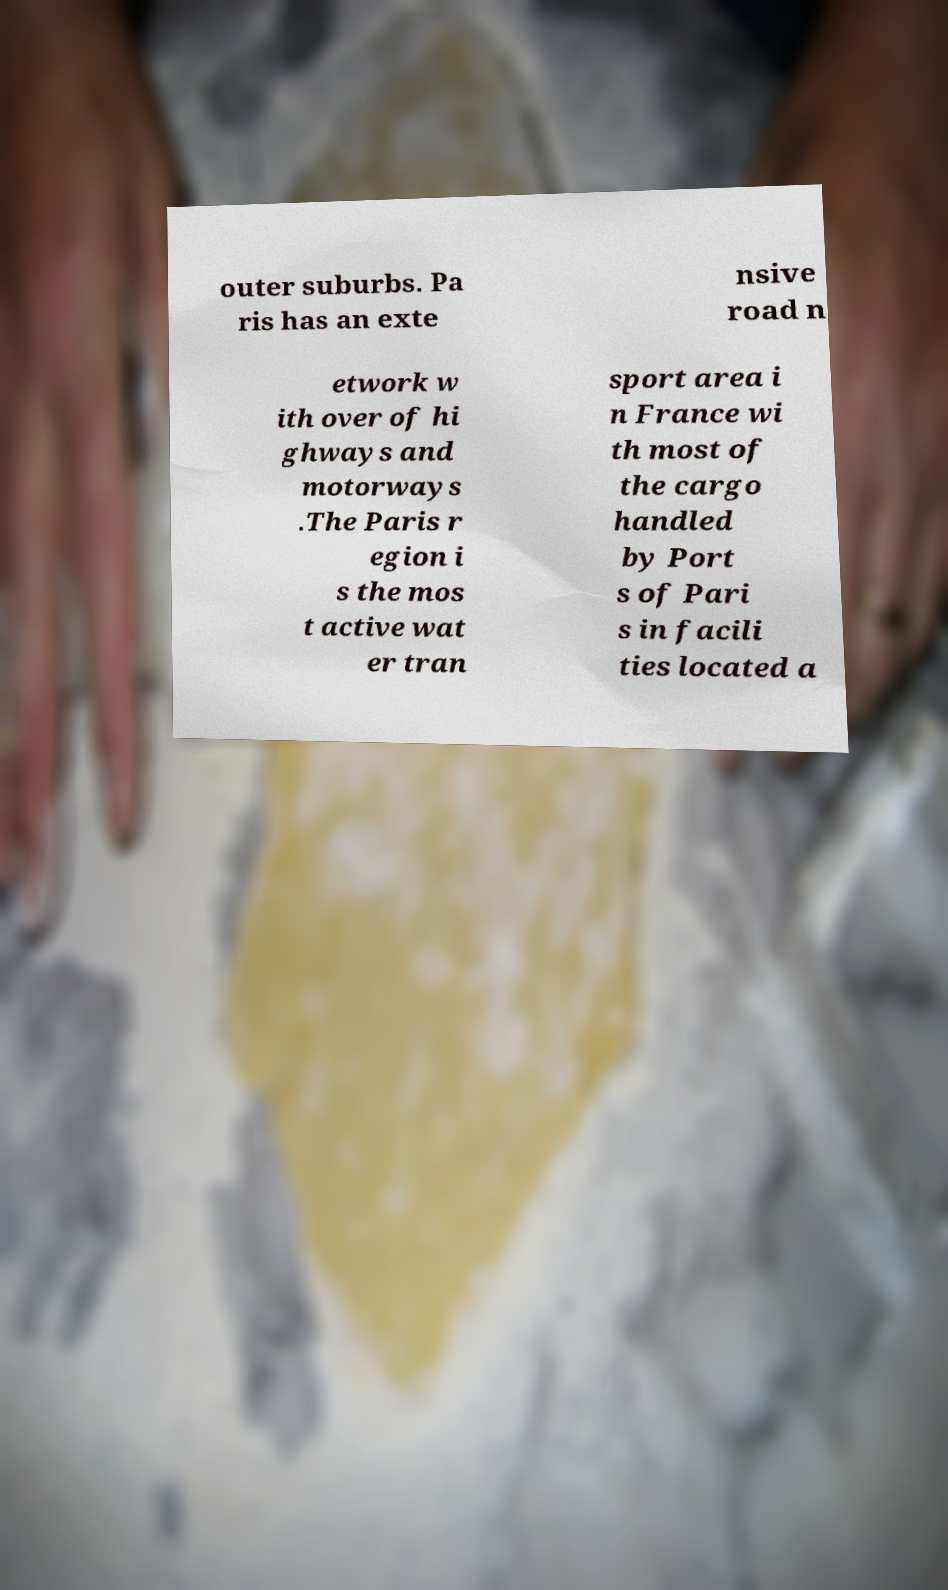For documentation purposes, I need the text within this image transcribed. Could you provide that? outer suburbs. Pa ris has an exte nsive road n etwork w ith over of hi ghways and motorways .The Paris r egion i s the mos t active wat er tran sport area i n France wi th most of the cargo handled by Port s of Pari s in facili ties located a 